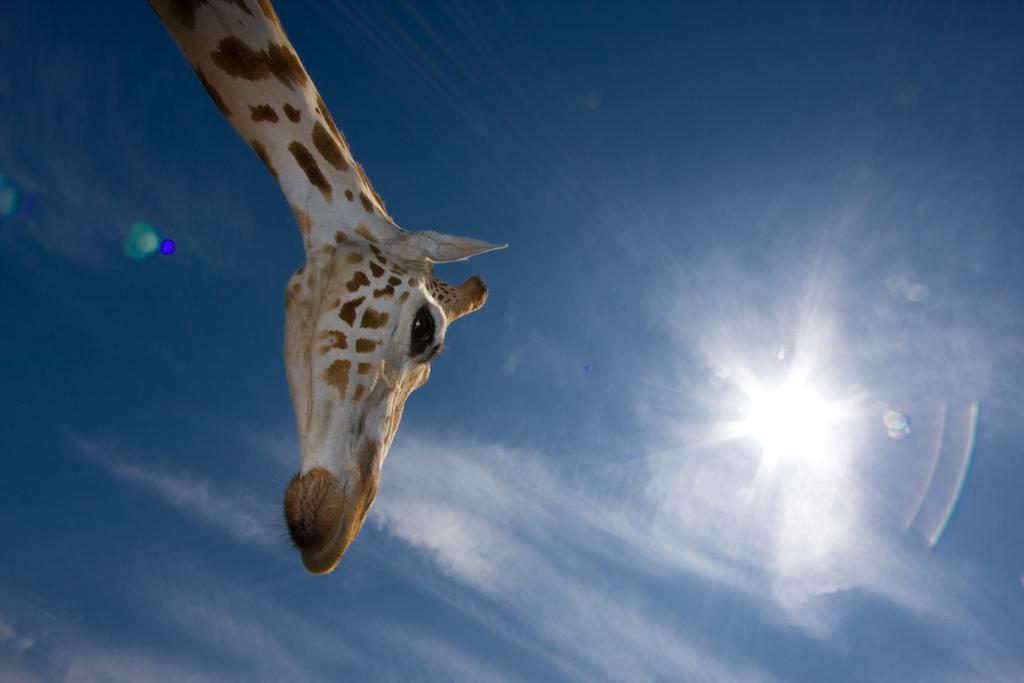In one or two sentences, can you explain what this image depicts? In this image there is giraffe, in the background there is blue sky and a sun. 